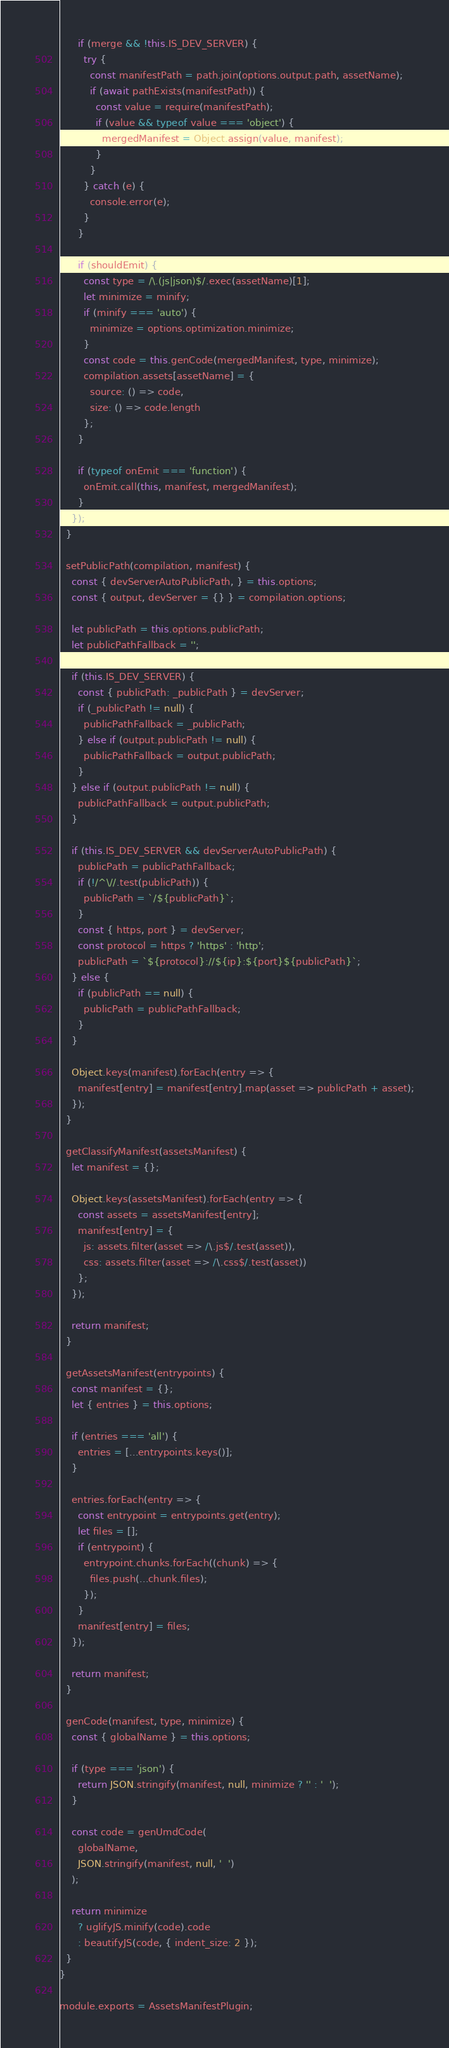<code> <loc_0><loc_0><loc_500><loc_500><_JavaScript_>      if (merge && !this.IS_DEV_SERVER) {
        try {
          const manifestPath = path.join(options.output.path, assetName);
          if (await pathExists(manifestPath)) {
            const value = require(manifestPath);
            if (value && typeof value === 'object') {
              mergedManifest = Object.assign(value, manifest);
            }
          }
        } catch (e) {
          console.error(e);
        }
      }

      if (shouldEmit) {
        const type = /\.(js|json)$/.exec(assetName)[1];
        let minimize = minify;
        if (minify === 'auto') {
          minimize = options.optimization.minimize;
        }
        const code = this.genCode(mergedManifest, type, minimize);
        compilation.assets[assetName] = {
          source: () => code,
          size: () => code.length
        };
      }

      if (typeof onEmit === 'function') {
        onEmit.call(this, manifest, mergedManifest);
      }
    });
  }

  setPublicPath(compilation, manifest) {
    const { devServerAutoPublicPath, } = this.options;
    const { output, devServer = {} } = compilation.options;

    let publicPath = this.options.publicPath;
    let publicPathFallback = '';

    if (this.IS_DEV_SERVER) {
      const { publicPath: _publicPath } = devServer;
      if (_publicPath != null) {
        publicPathFallback = _publicPath;
      } else if (output.publicPath != null) {
        publicPathFallback = output.publicPath;
      }
    } else if (output.publicPath != null) {
      publicPathFallback = output.publicPath;
    }

    if (this.IS_DEV_SERVER && devServerAutoPublicPath) {
      publicPath = publicPathFallback;
      if (!/^\//.test(publicPath)) {
        publicPath = `/${publicPath}`;
      }
      const { https, port } = devServer;
      const protocol = https ? 'https' : 'http';
      publicPath = `${protocol}://${ip}:${port}${publicPath}`;
    } else {
      if (publicPath == null) {
        publicPath = publicPathFallback;
      }
    }

    Object.keys(manifest).forEach(entry => {
      manifest[entry] = manifest[entry].map(asset => publicPath + asset);
    });
  }

  getClassifyManifest(assetsManifest) {
    let manifest = {};

    Object.keys(assetsManifest).forEach(entry => {
      const assets = assetsManifest[entry];
      manifest[entry] = {
        js: assets.filter(asset => /\.js$/.test(asset)),
        css: assets.filter(asset => /\.css$/.test(asset))
      };
    });

    return manifest;
  }

  getAssetsManifest(entrypoints) {
    const manifest = {};
    let { entries } = this.options;

    if (entries === 'all') {
      entries = [...entrypoints.keys()];
    }

    entries.forEach(entry => {
      const entrypoint = entrypoints.get(entry);
      let files = [];
      if (entrypoint) {
        entrypoint.chunks.forEach((chunk) => {
          files.push(...chunk.files);
        });
      }
      manifest[entry] = files;
    });

    return manifest;
  }

  genCode(manifest, type, minimize) {
    const { globalName } = this.options;

    if (type === 'json') {
      return JSON.stringify(manifest, null, minimize ? '' : '  ');
    }

    const code = genUmdCode(
      globalName,
      JSON.stringify(manifest, null, '  ')
    );

    return minimize
      ? uglifyJS.minify(code).code
      : beautifyJS(code, { indent_size: 2 });
  }
}

module.exports = AssetsManifestPlugin;
</code> 